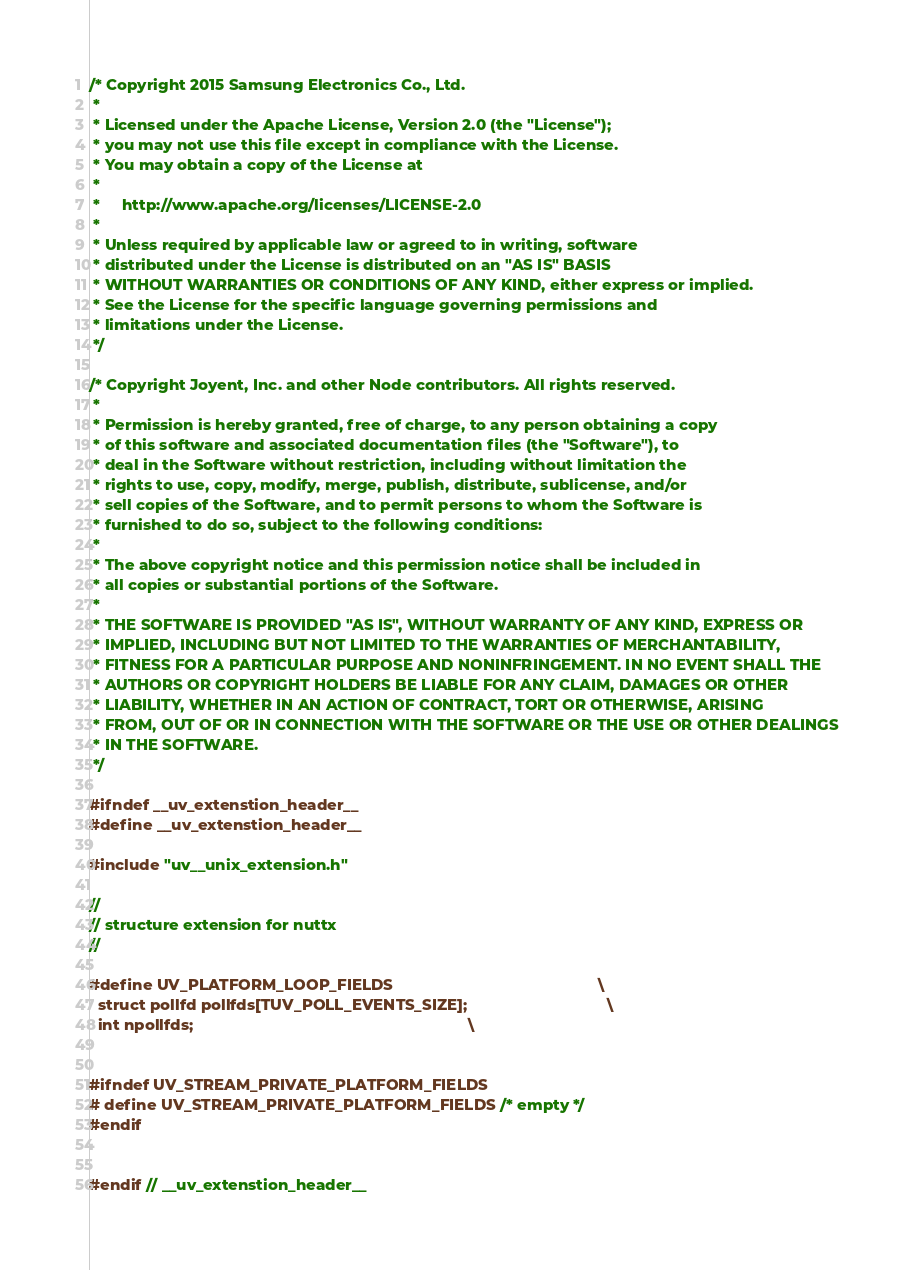Convert code to text. <code><loc_0><loc_0><loc_500><loc_500><_C_>/* Copyright 2015 Samsung Electronics Co., Ltd.
 *
 * Licensed under the Apache License, Version 2.0 (the "License");
 * you may not use this file except in compliance with the License.
 * You may obtain a copy of the License at
 *
 *     http://www.apache.org/licenses/LICENSE-2.0
 *
 * Unless required by applicable law or agreed to in writing, software
 * distributed under the License is distributed on an "AS IS" BASIS
 * WITHOUT WARRANTIES OR CONDITIONS OF ANY KIND, either express or implied.
 * See the License for the specific language governing permissions and
 * limitations under the License.
 */

/* Copyright Joyent, Inc. and other Node contributors. All rights reserved.
 *
 * Permission is hereby granted, free of charge, to any person obtaining a copy
 * of this software and associated documentation files (the "Software"), to
 * deal in the Software without restriction, including without limitation the
 * rights to use, copy, modify, merge, publish, distribute, sublicense, and/or
 * sell copies of the Software, and to permit persons to whom the Software is
 * furnished to do so, subject to the following conditions:
 *
 * The above copyright notice and this permission notice shall be included in
 * all copies or substantial portions of the Software.
 *
 * THE SOFTWARE IS PROVIDED "AS IS", WITHOUT WARRANTY OF ANY KIND, EXPRESS OR
 * IMPLIED, INCLUDING BUT NOT LIMITED TO THE WARRANTIES OF MERCHANTABILITY,
 * FITNESS FOR A PARTICULAR PURPOSE AND NONINFRINGEMENT. IN NO EVENT SHALL THE
 * AUTHORS OR COPYRIGHT HOLDERS BE LIABLE FOR ANY CLAIM, DAMAGES OR OTHER
 * LIABILITY, WHETHER IN AN ACTION OF CONTRACT, TORT OR OTHERWISE, ARISING
 * FROM, OUT OF OR IN CONNECTION WITH THE SOFTWARE OR THE USE OR OTHER DEALINGS
 * IN THE SOFTWARE.
 */

#ifndef __uv_extenstion_header__
#define __uv_extenstion_header__

#include "uv__unix_extension.h"

//
// structure extension for nuttx
//

#define UV_PLATFORM_LOOP_FIELDS                                               \
  struct pollfd pollfds[TUV_POLL_EVENTS_SIZE];                                \
  int npollfds;                                                               \


#ifndef UV_STREAM_PRIVATE_PLATFORM_FIELDS
# define UV_STREAM_PRIVATE_PLATFORM_FIELDS /* empty */
#endif


#endif // __uv_extenstion_header__
</code> 